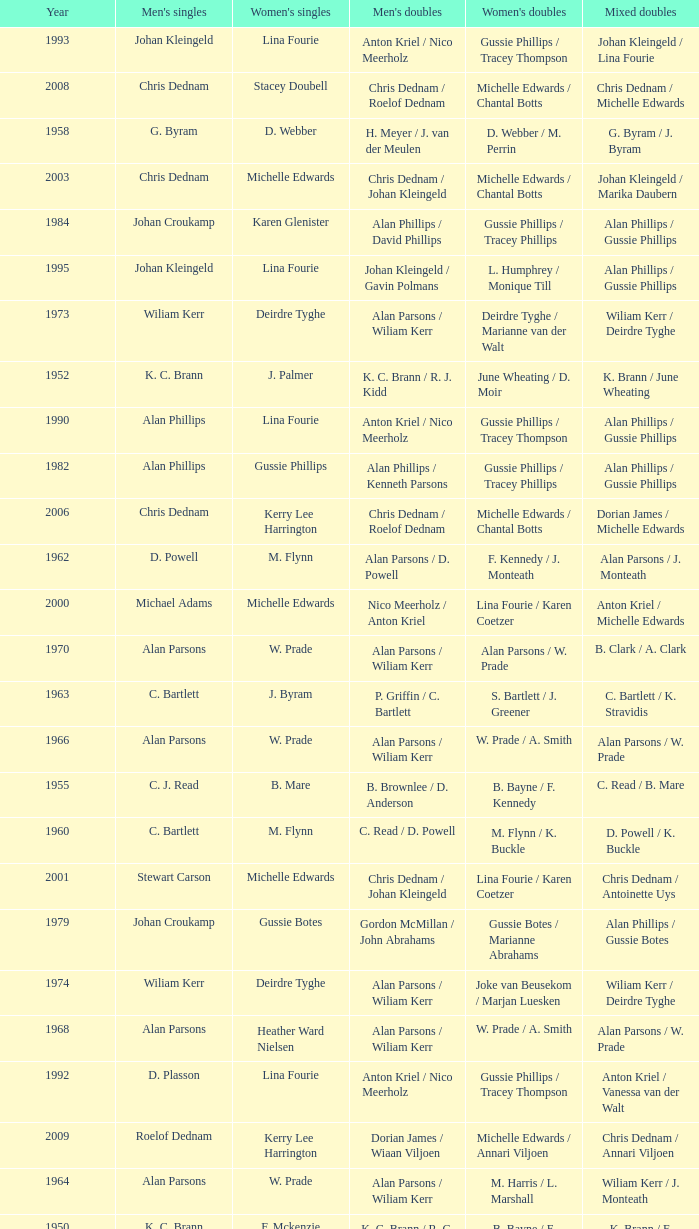Which Men's doubles have a Year smaller than 1960, and Men's singles of noel b. radford? R. C. Allen / E. S. Irwin. 